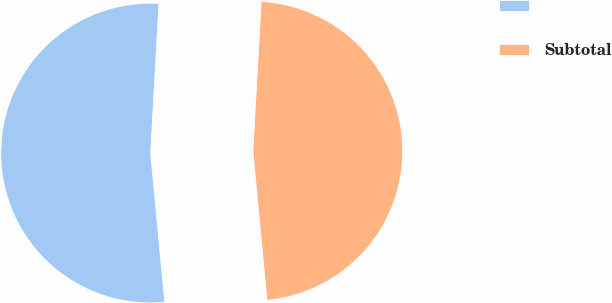Convert chart to OTSL. <chart><loc_0><loc_0><loc_500><loc_500><pie_chart><ecel><fcel>Subtotal<nl><fcel>52.38%<fcel>47.62%<nl></chart> 